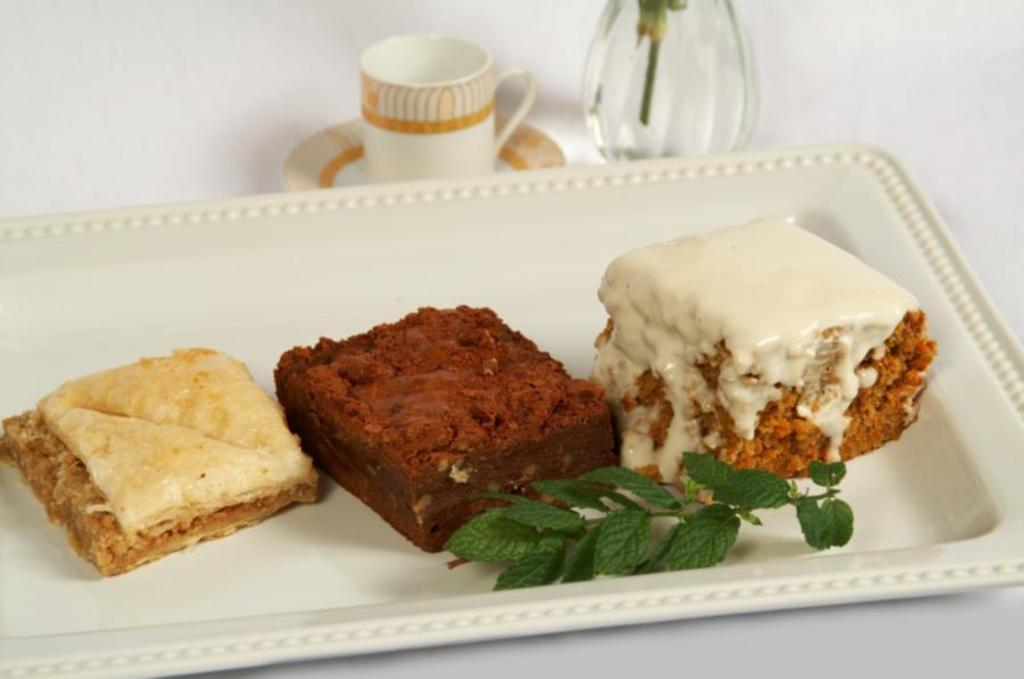What is on the white plate in the image? There are food items on a white plate in the image. What else can be seen on the surface along with the white plate? There are objects on the surface along with the white plate. What type of bubble is floating above the food items on the plate? There is no bubble present in the image. What time is displayed on the watch in the image? There is no watch present in the image. 